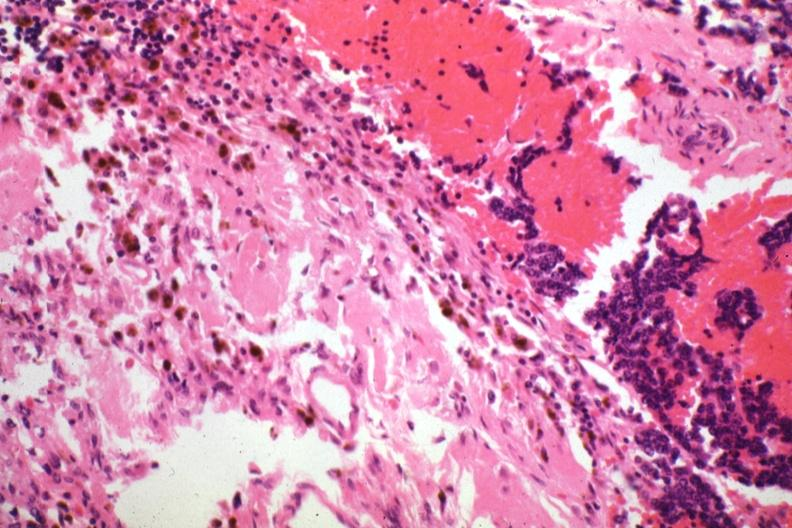what does this image show?
Answer the question using a single word or phrase. Tissue about tumor with tumor cells 